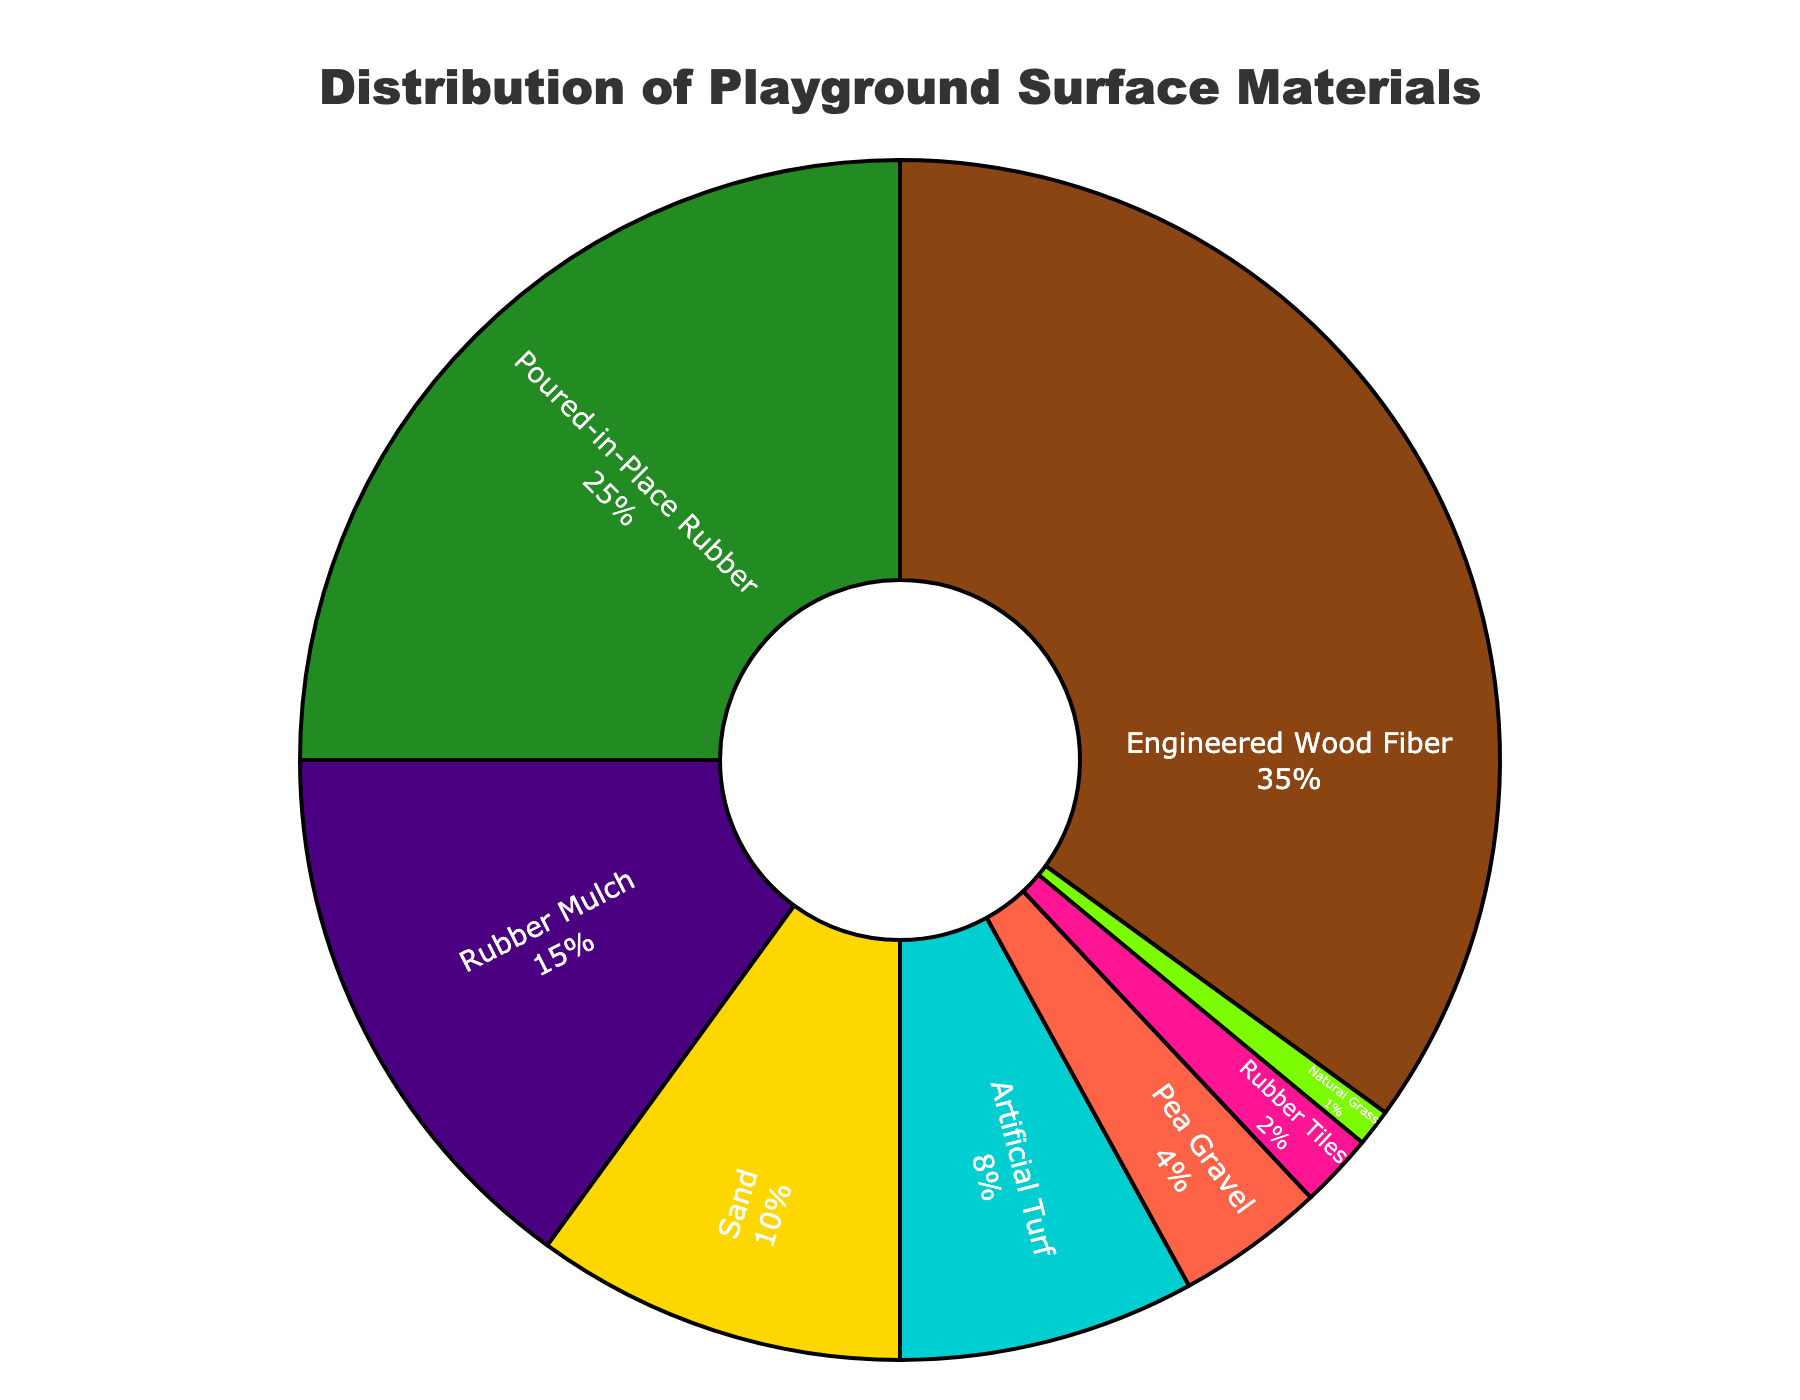Which playground surface material is used most frequently? The chart shows the percentage distribution of different playground surface materials used. The material with the largest percentage is Engineered Wood Fiber with 35%.
Answer: Engineered Wood Fiber What is the total percentage of surfaces made up of rubber-based materials? Adding the percentages for Poured-in-Place Rubber (25%), Rubber Mulch (15%), and Rubber Tiles (2%) gives the total percentage of rubber-based materials.
Answer: 42% Which material is used less frequently, Pea Gravel or Rubber Tiles? Comparing the percentages, Pea Gravel (4%) is more frequently used than Rubber Tiles (2%). Thus, Rubber Tiles is used less frequently.
Answer: Rubber Tiles What is the combined percentage of materials that are not rubber-based? Summing the percentages for Engineered Wood Fiber (35%), Sand (10%), Artificial Turf (8%), Pea Gravel (4%), and Natural Grass (1%) gives the combined percentage of non-rubber-based materials.
Answer: 58% Which materials together account for exactly half of the playground surfaces? Adding the percentages of the top two materials, Engineered Wood Fiber (35%) and Poured-in-Place Rubber (25%), provides a sum of 60%. Looking further, Engineered Wood Fiber (35%) and Rubber Mulch (15%) totals 50%. Thus, Engineered Wood Fiber and Rubber Mulch together make up 50%.
Answer: Engineered Wood Fiber and Rubber Mulch Is the use of Sand more than twice the use of Pea Gravel? Comparing Sand (10%) and Pea Gravel (4%), Sand's percentage (10) is more than twice Pea Gravel’s percentage (4 * 2 = 8).
Answer: Yes Subtract the percentage of Natural Grass from the percentage of Poured-in-Place Rubber. What is the result? Poured-in-Place Rubber is 25% and Natural Grass is 1%. Subtracting 1% from 25% gives 24%.
Answer: 24% What's the ratio of the use of Artificial Turf to the use of Sand? The percentage of Artificial Turf is 8% and Sand is 10%. The ratio 8:10 simplifies to 4:5.
Answer: 4:5 What percentage of playground surfaces are covered with materials other than Engineered Wood Fiber? Subtracting Engineered Wood Fiber's percentage (35%) from 100% gives the percentage of all other materials combined.
Answer: 65% Which material has the smallest percentage, and what is its color in the chart? Natural Grass has the smallest percentage (1%) and its color in the chart is green.
Answer: Natural Grass, green 